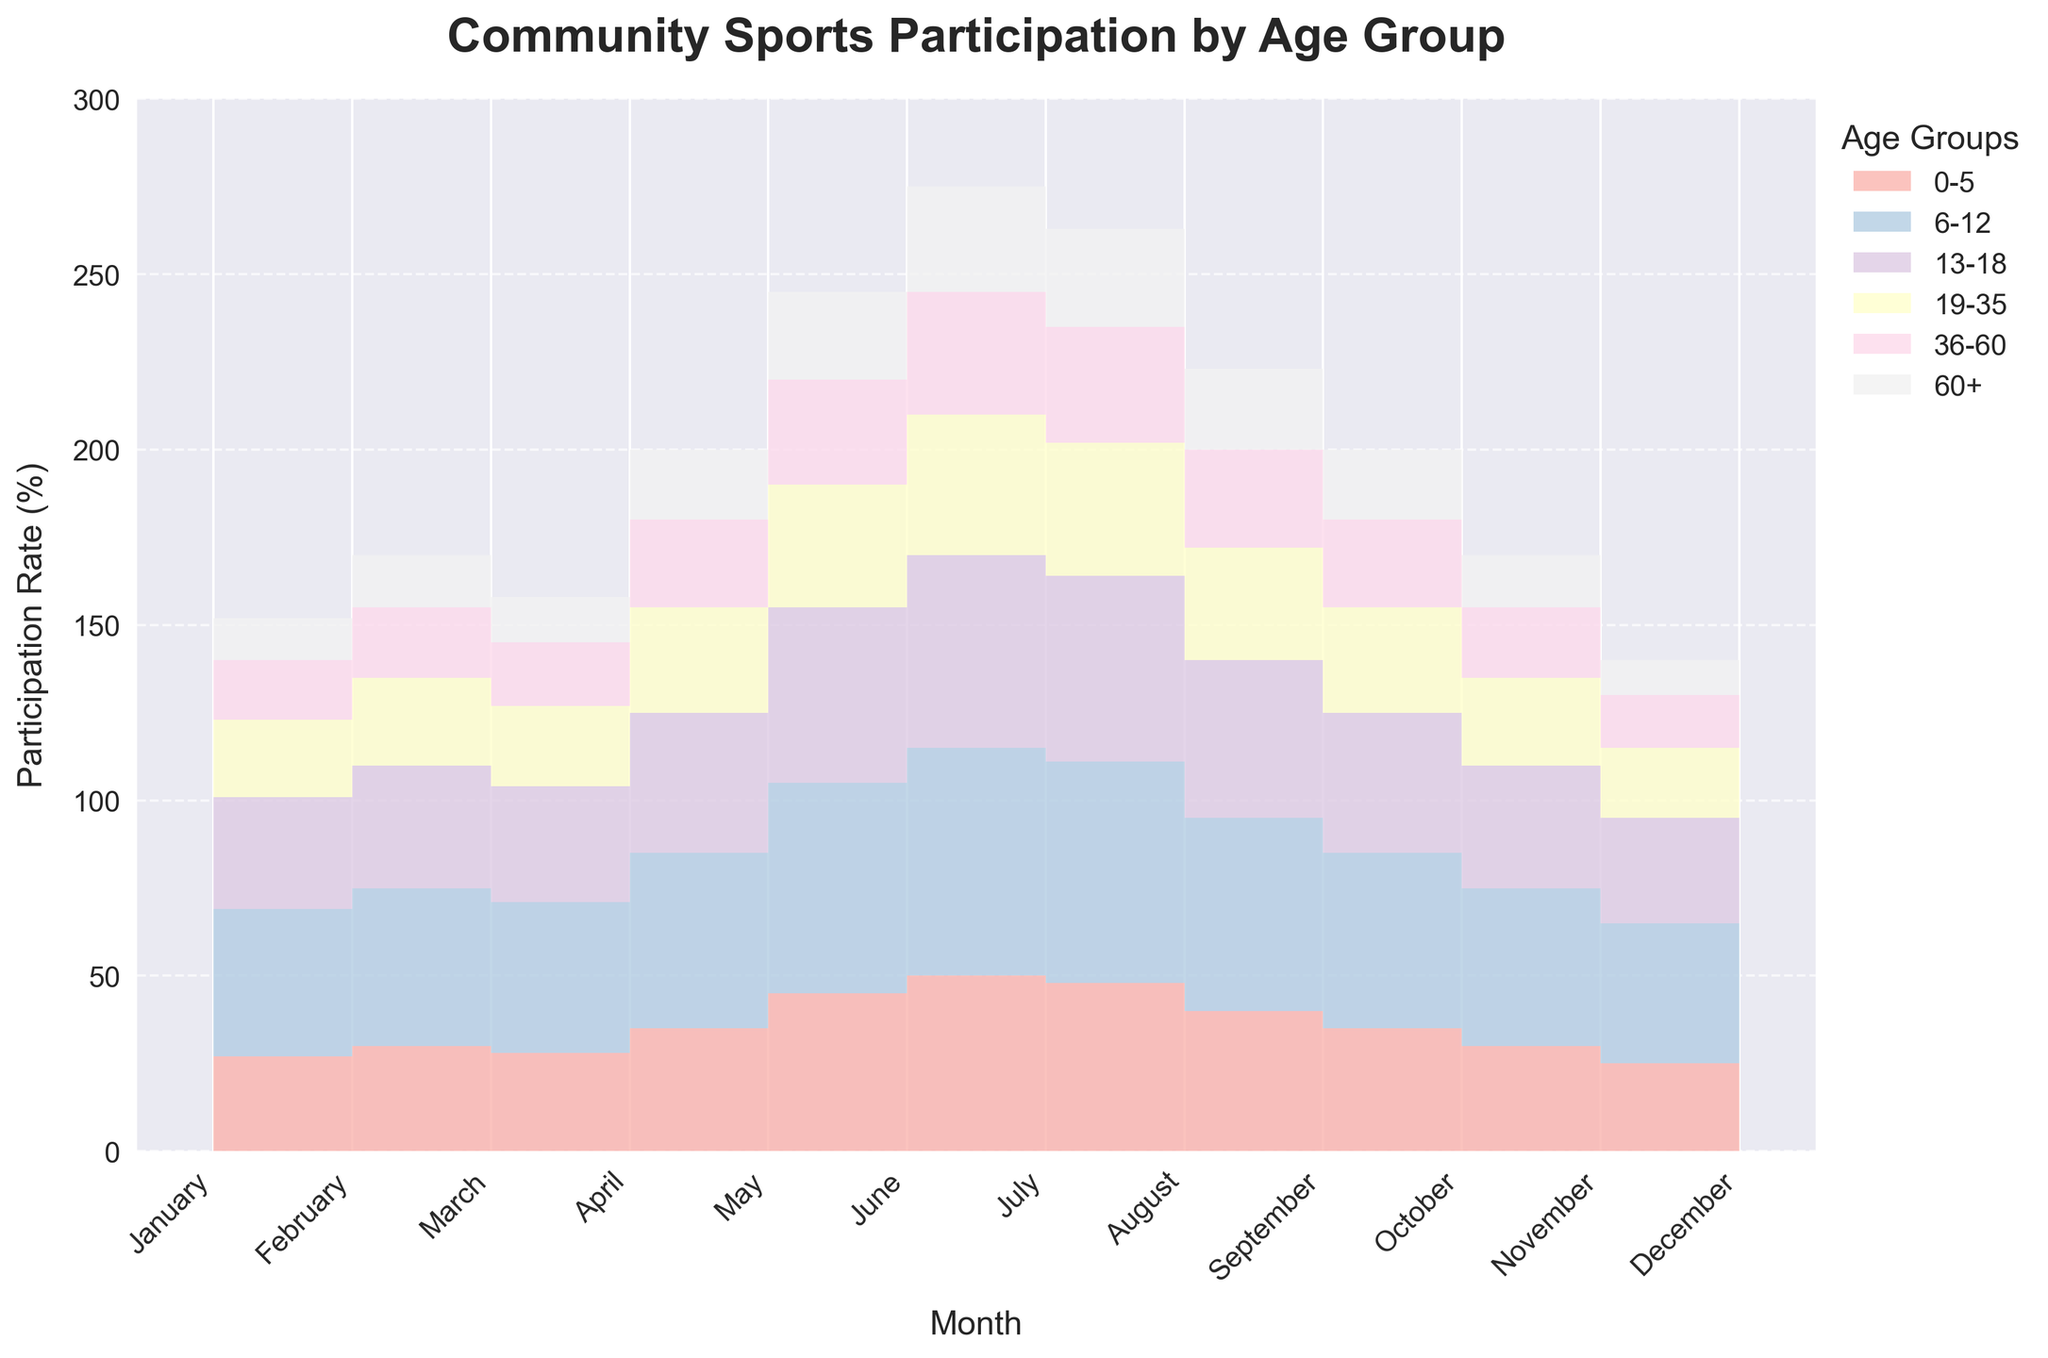What is the title of the figure? Look at the text at the top of the figure which describes what the chart is showing.
Answer: Community Sports Participation by Age Group Which age group has the highest participation rate in July? Locate the data points in July for each age group and identify the highest value.
Answer: 6-12 How does the participation rate of the 60+ age group in January compare to that in December? Compare the participation rates of the 60+ age group in January and December.
Answer: Equal Which month shows the highest overall participation rate across all age groups? Sum the participation rates of all age groups for each month and identify the month with the highest total.
Answer: July What is the participation rate difference for the 0-5 age group between May and September? Subtract the participation rate in May from the participation rate in September for the 0-5 age group.
Answer: 5 In which month does the 13-18 age group see a sharp increase in participation? Find the month where the data shows a steep rise in the participation rate for the 13-18 age group.
Answer: June How much does participation in the 36-60 age group decrease from July to December? Subtract the participation rate in December from the rate in July for the 36-60 age group.
Answer: 20 Which age group has the most stable participation rate throughout the year? Compare the variation (change in participation rates) for each age group across the months and identify the group with the least variation.
Answer: 19-35 What is the total participation rate for the 6-12 age group for the first half of the year (January to June)? Sum the participation rates from January to June for the 6-12 age group.
Answer: 280 Between which two months does the 19-35 age group see the largest drop in participation rate? Compare the month-to-month changes in participation rate for the 19-35 age group and identify the largest drop.
Answer: August to September 